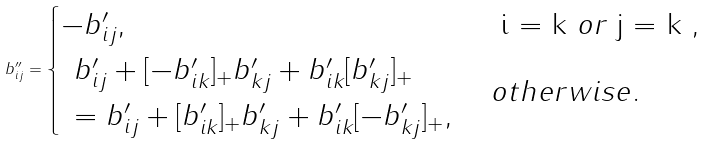<formula> <loc_0><loc_0><loc_500><loc_500>b ^ { \prime \prime } _ { i j } = \begin{cases} - b ^ { \prime } _ { i j } , & $ i = k $ o r $ j = k $ , \\ \, \begin{array} { l } b ^ { \prime } _ { i j } + [ - b ^ { \prime } _ { i k } ] _ { + } b ^ { \prime } _ { k j } + b ^ { \prime } _ { i k } [ b ^ { \prime } _ { k j } ] _ { + } \\ = b ^ { \prime } _ { i j } + [ b ^ { \prime } _ { i k } ] _ { + } b ^ { \prime } _ { k j } + b ^ { \prime } _ { i k } [ - b ^ { \prime } _ { k j } ] _ { + } , \end{array} & o t h e r w i s e . \end{cases}</formula> 